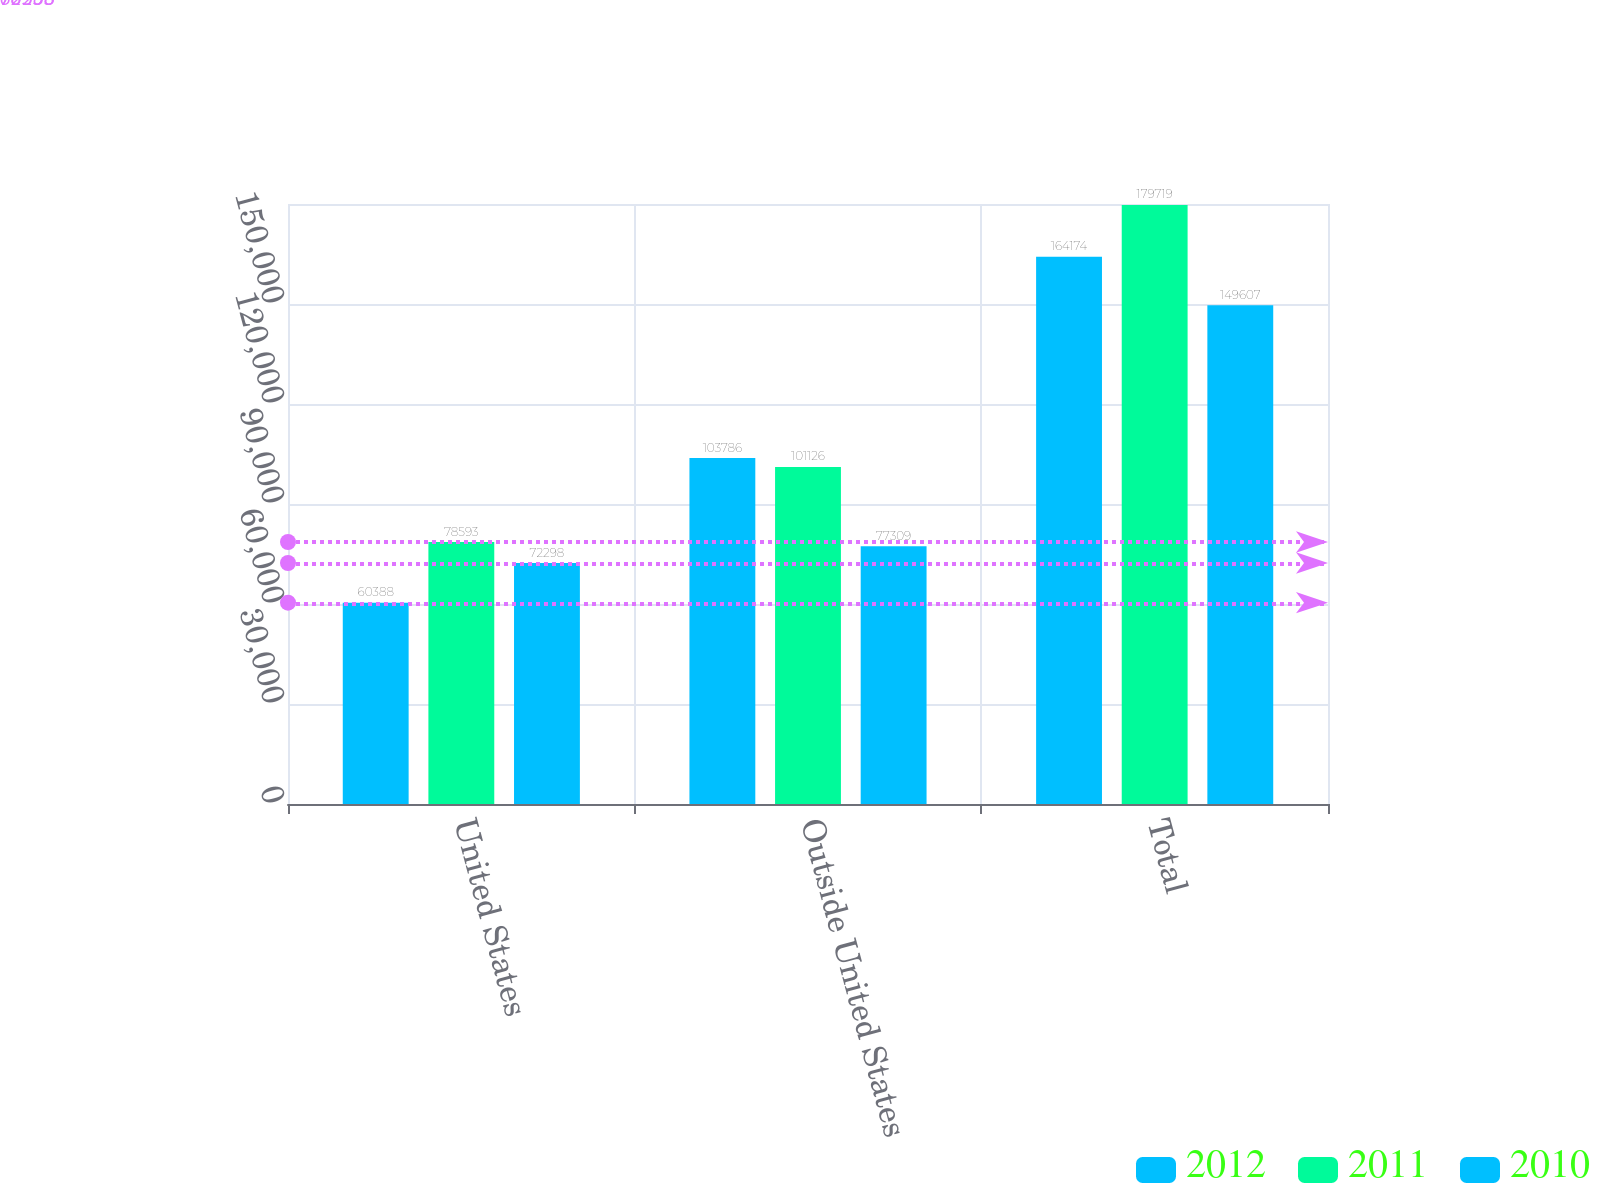Convert chart. <chart><loc_0><loc_0><loc_500><loc_500><stacked_bar_chart><ecel><fcel>United States<fcel>Outside United States<fcel>Total<nl><fcel>2012<fcel>60388<fcel>103786<fcel>164174<nl><fcel>2011<fcel>78593<fcel>101126<fcel>179719<nl><fcel>2010<fcel>72298<fcel>77309<fcel>149607<nl></chart> 